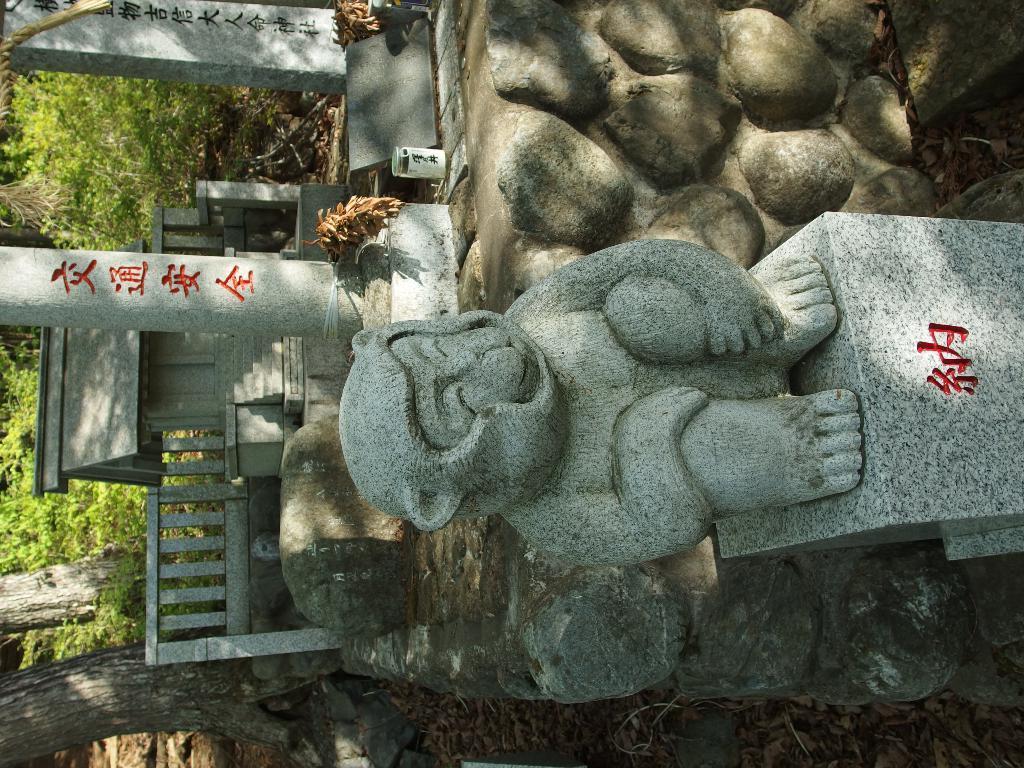How would you summarize this image in a sentence or two? In this image there is a sculpture and there are poles. At the bottom there is a fence. In the background there are trees. 